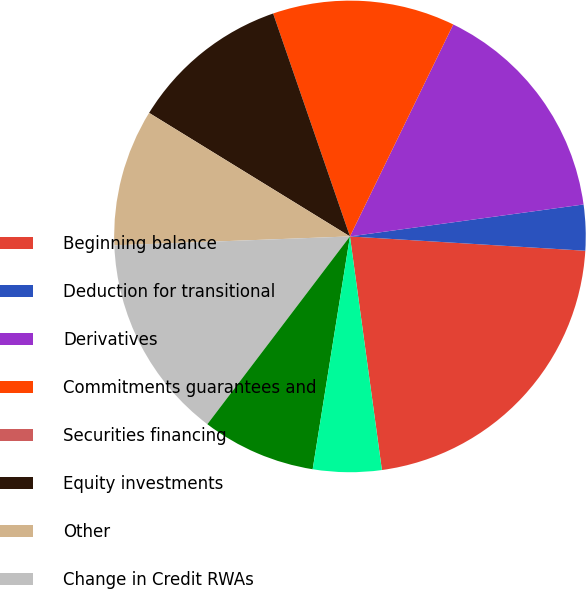Convert chart. <chart><loc_0><loc_0><loc_500><loc_500><pie_chart><fcel>Beginning balance<fcel>Deduction for transitional<fcel>Derivatives<fcel>Commitments guarantees and<fcel>Securities financing<fcel>Equity investments<fcel>Other<fcel>Change in Credit RWAs<fcel>Regulatory VaR<fcel>Stressed VaR<nl><fcel>21.87%<fcel>3.13%<fcel>15.62%<fcel>12.5%<fcel>0.0%<fcel>10.94%<fcel>9.38%<fcel>14.06%<fcel>7.81%<fcel>4.69%<nl></chart> 